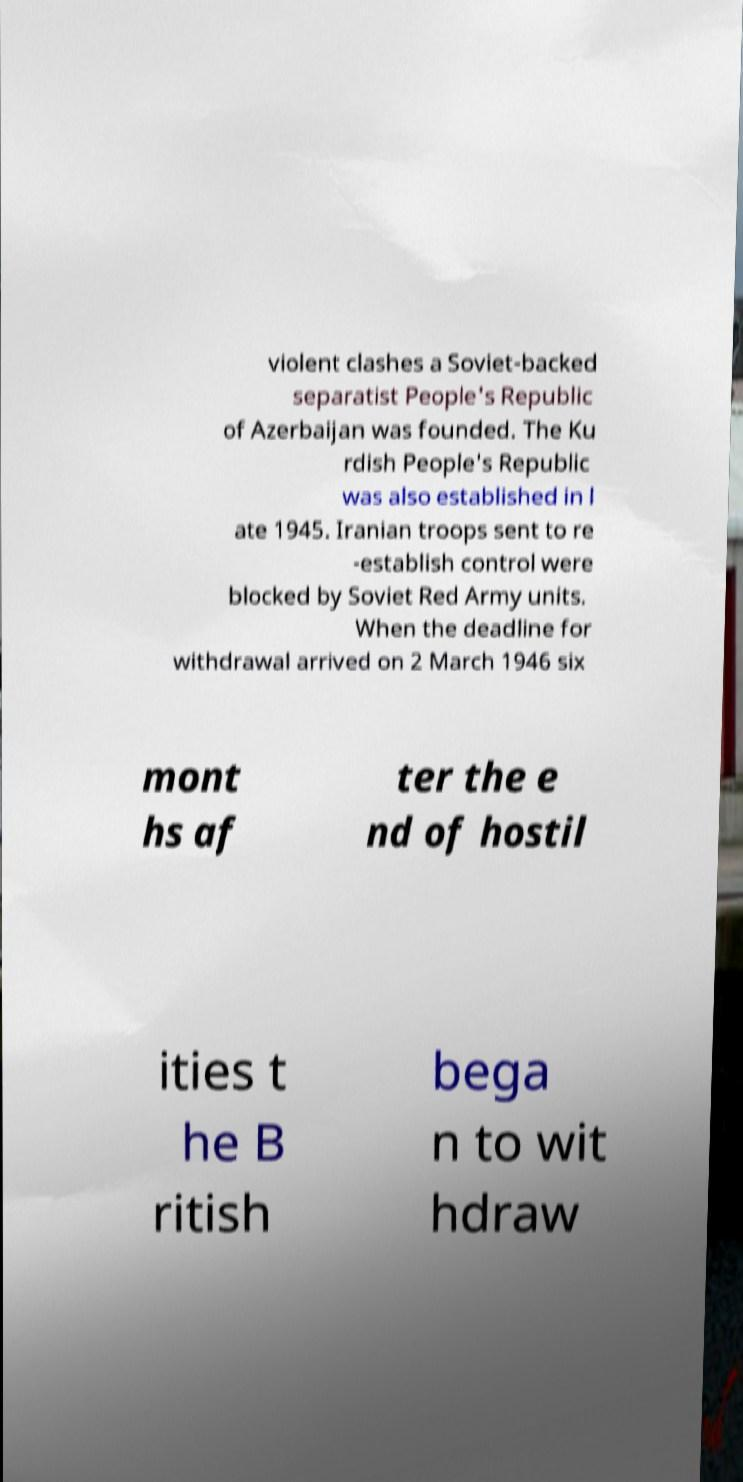Could you extract and type out the text from this image? violent clashes a Soviet-backed separatist People's Republic of Azerbaijan was founded. The Ku rdish People's Republic was also established in l ate 1945. Iranian troops sent to re -establish control were blocked by Soviet Red Army units. When the deadline for withdrawal arrived on 2 March 1946 six mont hs af ter the e nd of hostil ities t he B ritish bega n to wit hdraw 